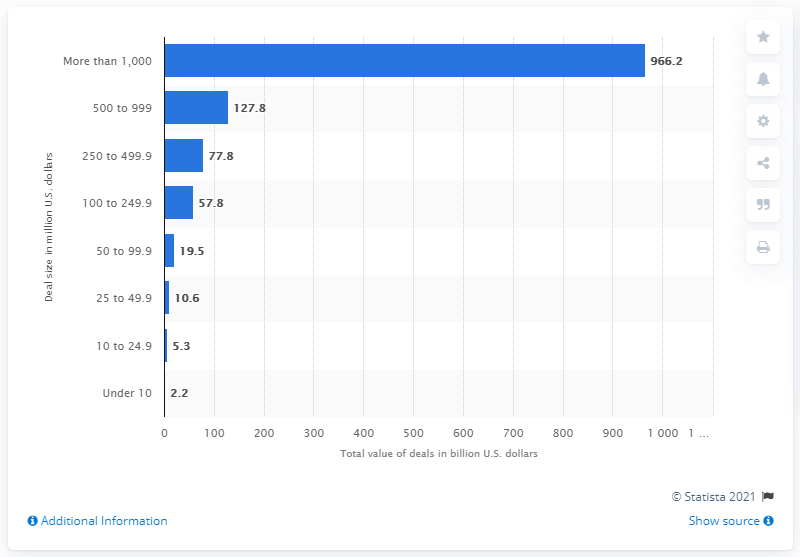Outline some significant characteristics in this image. There were 200 merger and acquisition transactions between 500 and 999 million U.S. dollars in total, with a combined value of 127.8 billion U.S. dollars. 